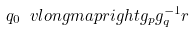Convert formula to latex. <formula><loc_0><loc_0><loc_500><loc_500>q _ { 0 } \ v l o n g m a p r i g h t { g _ { p } g _ { q } ^ { - 1 } } r</formula> 